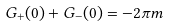<formula> <loc_0><loc_0><loc_500><loc_500>G _ { + } ( 0 ) + G _ { - } ( 0 ) = - 2 \pi m</formula> 